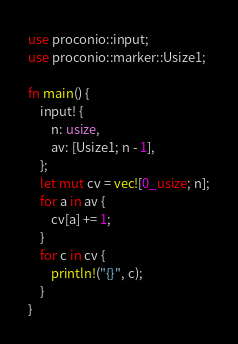Convert code to text. <code><loc_0><loc_0><loc_500><loc_500><_Rust_>use proconio::input;
use proconio::marker::Usize1;

fn main() {
    input! {
        n: usize,
        av: [Usize1; n - 1],
    };
    let mut cv = vec![0_usize; n];
    for a in av {
        cv[a] += 1;
    }
    for c in cv {
        println!("{}", c);
    }
}
</code> 